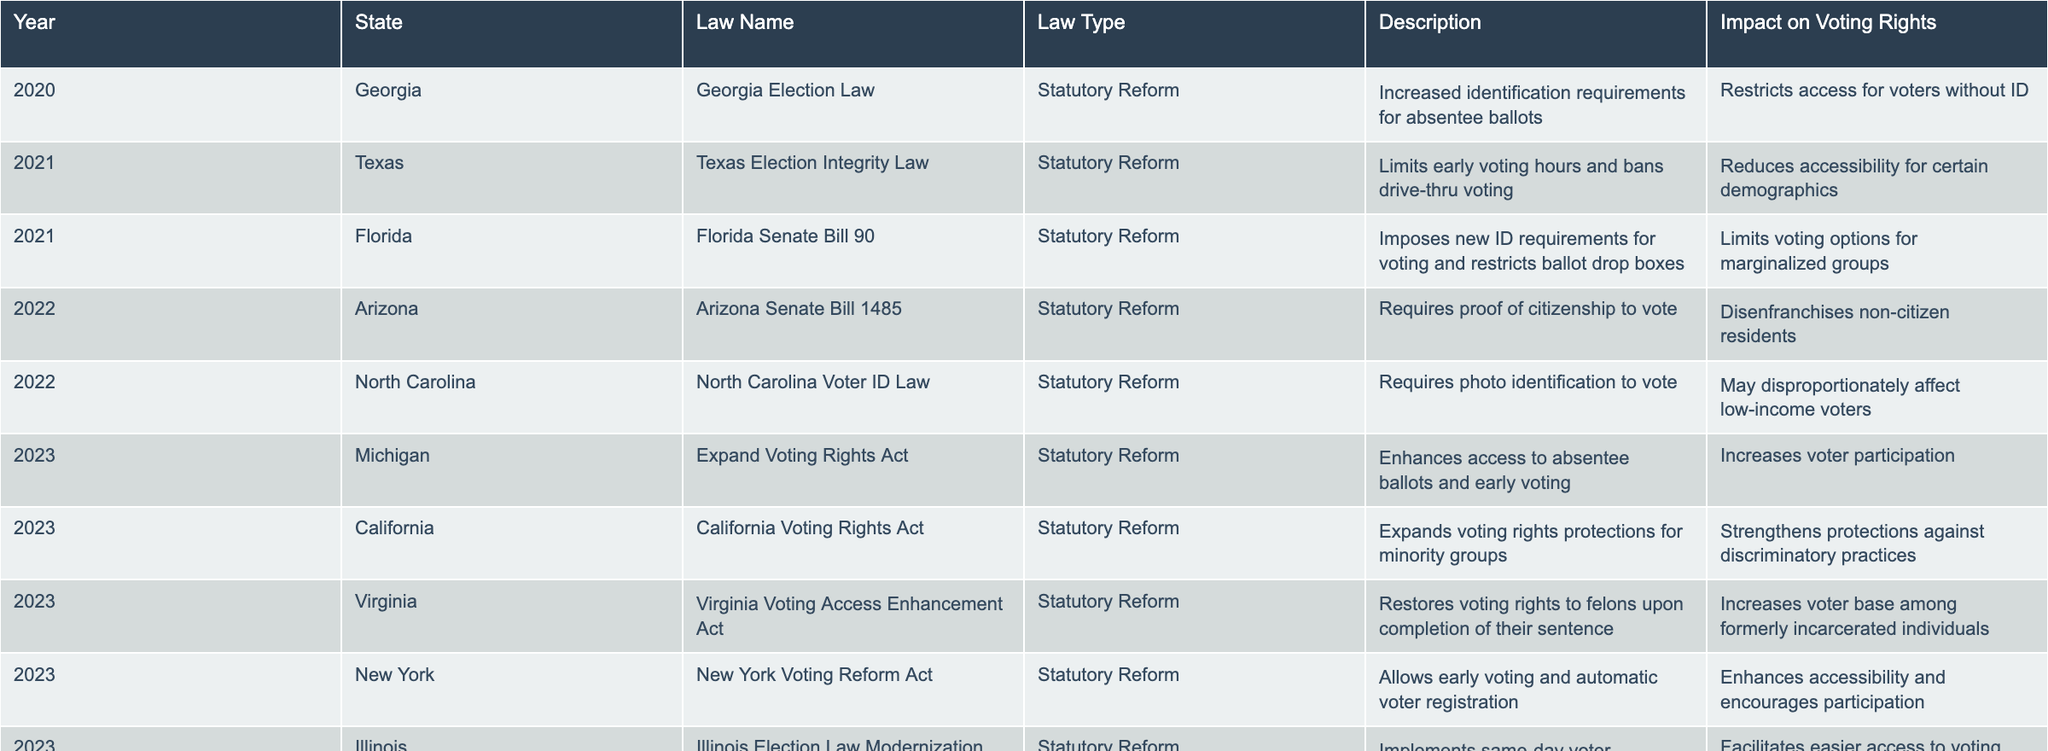What is the law passed by Michigan in 2023? The table indicates that Michigan passed the "Expand Voting Rights Act" in 2023.
Answer: Expand Voting Rights Act Which state law requires proof of citizenship to vote? The table shows that the "Arizona Senate Bill 1485" from Arizona mandates proof of citizenship for voting.
Answer: Arizona Senate Bill 1485 How many states implemented voting laws in 2021? The table lists two laws from 2021: Texas and Florida, so there are two states.
Answer: 2 What is the main impact of the Florida Senate Bill 90 on voting rights? According to the description, it limits voting options for marginalized groups, indicating its restrictive impact on accessibility.
Answer: Limits voting options for marginalized groups Did California pass any voting rights law that strengthens protections against discriminatory practices? Yes, the California Voting Rights Act passed in 2023 aims to expand voting rights protections for minority groups, confirming a positive effect on discrimination.
Answer: Yes Which year had the highest number of laws passed related to voting rights according to the table? By reviewing the years, 2023 has the most laws listed, specifically four, indicating it had the highest number of voting rights laws passed.
Answer: 2023 What type of law did Virginia pass in 2023, and what was its impact? Virginia passed the "Virginia Voting Access Enhancement Act," which restores voting rights to felons, thereby increasing the voter base among formerly incarcerated individuals.
Answer: Restores voting rights to felons Are there any laws in the table that specifically target the restoration of voting rights to felons? Yes, the "Virginia Voting Access Enhancement Act" aims to restore voting rights to felons upon completion of their sentence, demonstrating a commitment to reintegration.
Answer: Yes Calculate the total number of restrictive versus expansive laws introduced from 2020 to 2023. Restrictive laws include those in Georgia, Texas, Florida, Arizona, and North Carolina (5 total). Expansive laws are from Michigan, California, Virginia, New York, and Illinois (5 total). This results in an equal distribution of restrictive and expansive laws.
Answer: 5 restrictive, 5 expansive What is the significance of the New York Voting Reform Act of 2023? Its significance lies in allowing early voting and automatic voter registration, thereby enhancing accessibility and encouraging voter participation.
Answer: Enhances accessibility and encourages participation Is there any law that has been identified as having a likely negative impact on low-income voters? Yes, the North Carolina Voter ID Law may disproportionately affect low-income voters according to its description in the table.
Answer: Yes 